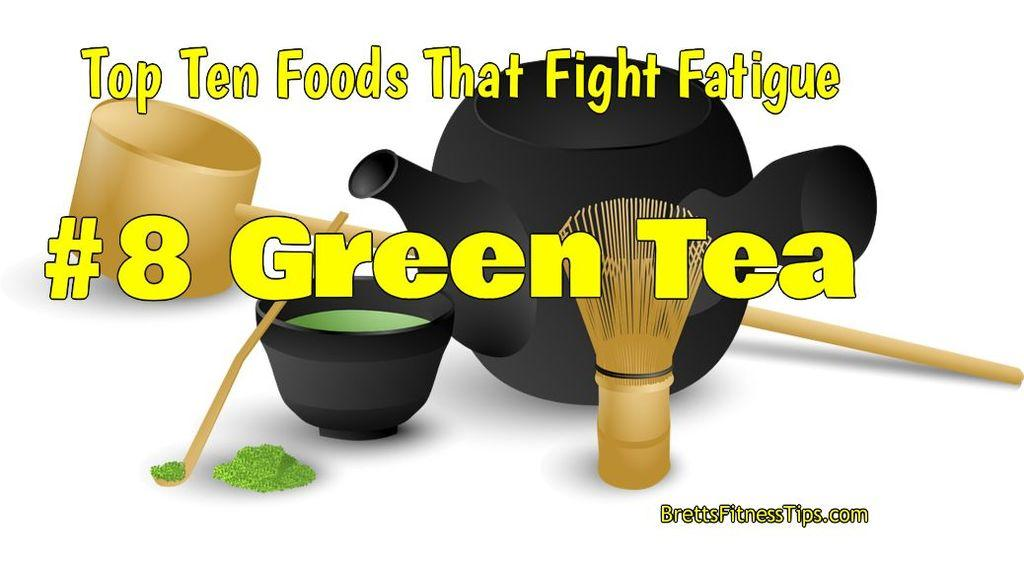What is the main visual element in the image? There is a poster in the image. What else can be seen in the image besides the poster? There are objects and text visible in the image. What type of mint is being used to attract customers in the image? There is no mint or reference to attracting customers in the image; it only features a poster, objects, and text. 